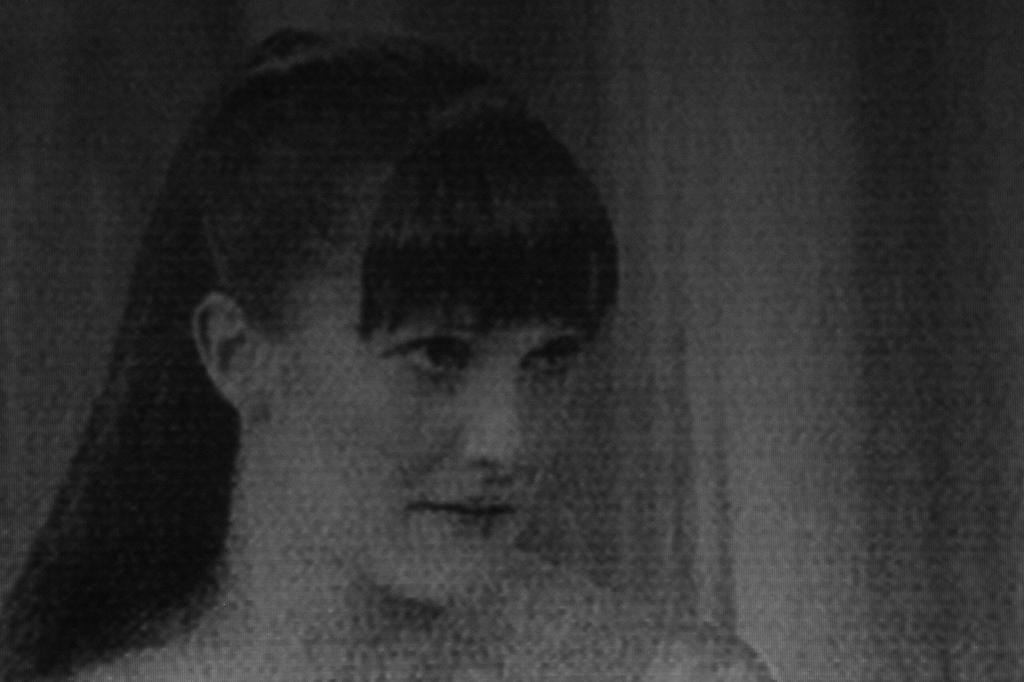Who is the main subject in the image? There is a woman in the image. Can you describe the woman's appearance? The woman has long hair. What else can be seen in the image besides the woman? There is a curtain in the image. What color is the curtain? The curtain is white in color. What type of pets does the woman have in the image? There are no pets visible in the image. What town is the woman from in the image? The image does not provide information about the woman's town or origin. 